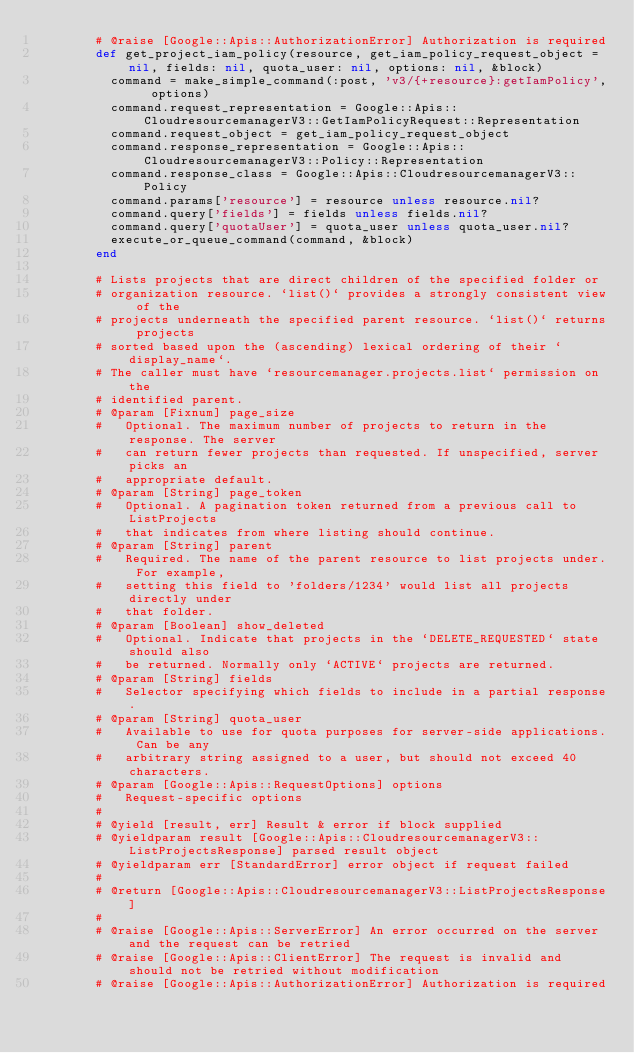<code> <loc_0><loc_0><loc_500><loc_500><_Ruby_>        # @raise [Google::Apis::AuthorizationError] Authorization is required
        def get_project_iam_policy(resource, get_iam_policy_request_object = nil, fields: nil, quota_user: nil, options: nil, &block)
          command = make_simple_command(:post, 'v3/{+resource}:getIamPolicy', options)
          command.request_representation = Google::Apis::CloudresourcemanagerV3::GetIamPolicyRequest::Representation
          command.request_object = get_iam_policy_request_object
          command.response_representation = Google::Apis::CloudresourcemanagerV3::Policy::Representation
          command.response_class = Google::Apis::CloudresourcemanagerV3::Policy
          command.params['resource'] = resource unless resource.nil?
          command.query['fields'] = fields unless fields.nil?
          command.query['quotaUser'] = quota_user unless quota_user.nil?
          execute_or_queue_command(command, &block)
        end
        
        # Lists projects that are direct children of the specified folder or
        # organization resource. `list()` provides a strongly consistent view of the
        # projects underneath the specified parent resource. `list()` returns projects
        # sorted based upon the (ascending) lexical ordering of their `display_name`.
        # The caller must have `resourcemanager.projects.list` permission on the
        # identified parent.
        # @param [Fixnum] page_size
        #   Optional. The maximum number of projects to return in the response. The server
        #   can return fewer projects than requested. If unspecified, server picks an
        #   appropriate default.
        # @param [String] page_token
        #   Optional. A pagination token returned from a previous call to ListProjects
        #   that indicates from where listing should continue.
        # @param [String] parent
        #   Required. The name of the parent resource to list projects under. For example,
        #   setting this field to 'folders/1234' would list all projects directly under
        #   that folder.
        # @param [Boolean] show_deleted
        #   Optional. Indicate that projects in the `DELETE_REQUESTED` state should also
        #   be returned. Normally only `ACTIVE` projects are returned.
        # @param [String] fields
        #   Selector specifying which fields to include in a partial response.
        # @param [String] quota_user
        #   Available to use for quota purposes for server-side applications. Can be any
        #   arbitrary string assigned to a user, but should not exceed 40 characters.
        # @param [Google::Apis::RequestOptions] options
        #   Request-specific options
        #
        # @yield [result, err] Result & error if block supplied
        # @yieldparam result [Google::Apis::CloudresourcemanagerV3::ListProjectsResponse] parsed result object
        # @yieldparam err [StandardError] error object if request failed
        #
        # @return [Google::Apis::CloudresourcemanagerV3::ListProjectsResponse]
        #
        # @raise [Google::Apis::ServerError] An error occurred on the server and the request can be retried
        # @raise [Google::Apis::ClientError] The request is invalid and should not be retried without modification
        # @raise [Google::Apis::AuthorizationError] Authorization is required</code> 